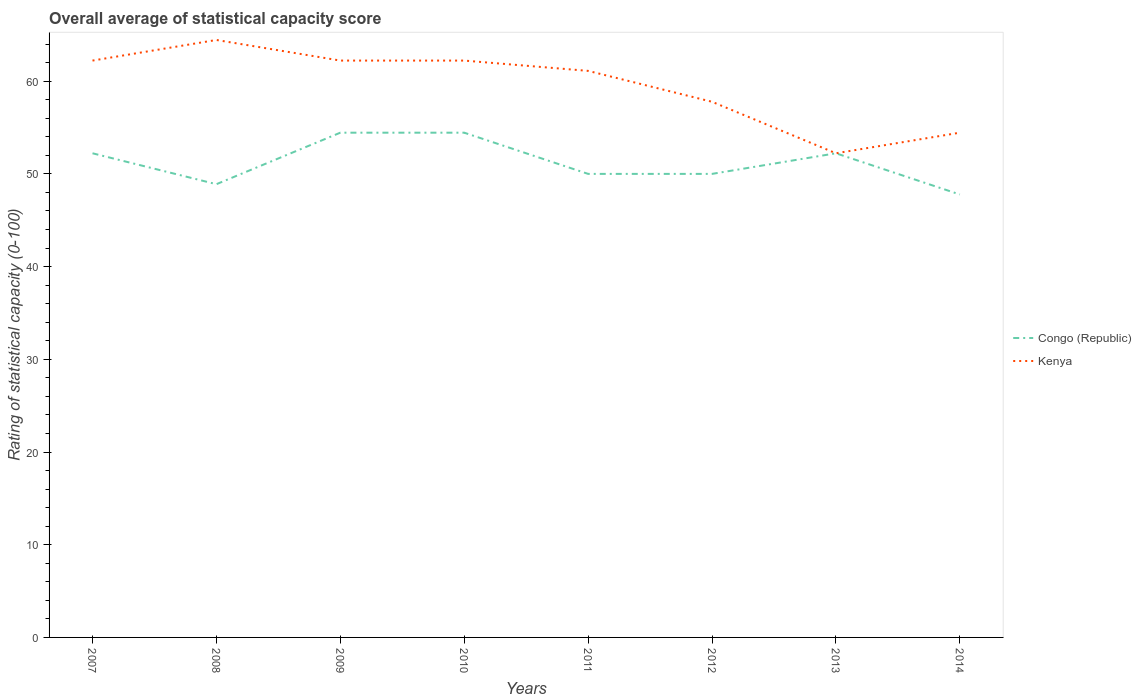Does the line corresponding to Congo (Republic) intersect with the line corresponding to Kenya?
Your response must be concise. Yes. Is the number of lines equal to the number of legend labels?
Offer a terse response. Yes. Across all years, what is the maximum rating of statistical capacity in Congo (Republic)?
Your response must be concise. 47.78. In which year was the rating of statistical capacity in Congo (Republic) maximum?
Your answer should be very brief. 2014. What is the total rating of statistical capacity in Congo (Republic) in the graph?
Offer a very short reply. 0. What is the difference between the highest and the second highest rating of statistical capacity in Kenya?
Your response must be concise. 12.22. Is the rating of statistical capacity in Congo (Republic) strictly greater than the rating of statistical capacity in Kenya over the years?
Keep it short and to the point. No. How many years are there in the graph?
Your response must be concise. 8. Are the values on the major ticks of Y-axis written in scientific E-notation?
Your answer should be compact. No. Does the graph contain any zero values?
Your answer should be very brief. No. Does the graph contain grids?
Your response must be concise. No. How many legend labels are there?
Offer a very short reply. 2. What is the title of the graph?
Offer a very short reply. Overall average of statistical capacity score. What is the label or title of the X-axis?
Make the answer very short. Years. What is the label or title of the Y-axis?
Make the answer very short. Rating of statistical capacity (0-100). What is the Rating of statistical capacity (0-100) in Congo (Republic) in 2007?
Offer a terse response. 52.22. What is the Rating of statistical capacity (0-100) of Kenya in 2007?
Provide a short and direct response. 62.22. What is the Rating of statistical capacity (0-100) of Congo (Republic) in 2008?
Offer a very short reply. 48.89. What is the Rating of statistical capacity (0-100) of Kenya in 2008?
Provide a succinct answer. 64.44. What is the Rating of statistical capacity (0-100) in Congo (Republic) in 2009?
Provide a succinct answer. 54.44. What is the Rating of statistical capacity (0-100) of Kenya in 2009?
Your answer should be very brief. 62.22. What is the Rating of statistical capacity (0-100) in Congo (Republic) in 2010?
Your answer should be compact. 54.44. What is the Rating of statistical capacity (0-100) of Kenya in 2010?
Keep it short and to the point. 62.22. What is the Rating of statistical capacity (0-100) in Kenya in 2011?
Give a very brief answer. 61.11. What is the Rating of statistical capacity (0-100) in Congo (Republic) in 2012?
Make the answer very short. 50. What is the Rating of statistical capacity (0-100) in Kenya in 2012?
Offer a terse response. 57.78. What is the Rating of statistical capacity (0-100) in Congo (Republic) in 2013?
Your response must be concise. 52.22. What is the Rating of statistical capacity (0-100) in Kenya in 2013?
Your response must be concise. 52.22. What is the Rating of statistical capacity (0-100) in Congo (Republic) in 2014?
Give a very brief answer. 47.78. What is the Rating of statistical capacity (0-100) in Kenya in 2014?
Ensure brevity in your answer.  54.44. Across all years, what is the maximum Rating of statistical capacity (0-100) of Congo (Republic)?
Keep it short and to the point. 54.44. Across all years, what is the maximum Rating of statistical capacity (0-100) in Kenya?
Provide a succinct answer. 64.44. Across all years, what is the minimum Rating of statistical capacity (0-100) of Congo (Republic)?
Your response must be concise. 47.78. Across all years, what is the minimum Rating of statistical capacity (0-100) of Kenya?
Keep it short and to the point. 52.22. What is the total Rating of statistical capacity (0-100) in Congo (Republic) in the graph?
Keep it short and to the point. 410. What is the total Rating of statistical capacity (0-100) in Kenya in the graph?
Your answer should be compact. 476.67. What is the difference between the Rating of statistical capacity (0-100) of Congo (Republic) in 2007 and that in 2008?
Offer a very short reply. 3.33. What is the difference between the Rating of statistical capacity (0-100) in Kenya in 2007 and that in 2008?
Offer a very short reply. -2.22. What is the difference between the Rating of statistical capacity (0-100) in Congo (Republic) in 2007 and that in 2009?
Provide a succinct answer. -2.22. What is the difference between the Rating of statistical capacity (0-100) in Kenya in 2007 and that in 2009?
Provide a short and direct response. 0. What is the difference between the Rating of statistical capacity (0-100) in Congo (Republic) in 2007 and that in 2010?
Offer a very short reply. -2.22. What is the difference between the Rating of statistical capacity (0-100) of Congo (Republic) in 2007 and that in 2011?
Give a very brief answer. 2.22. What is the difference between the Rating of statistical capacity (0-100) in Congo (Republic) in 2007 and that in 2012?
Make the answer very short. 2.22. What is the difference between the Rating of statistical capacity (0-100) in Kenya in 2007 and that in 2012?
Your answer should be very brief. 4.44. What is the difference between the Rating of statistical capacity (0-100) in Kenya in 2007 and that in 2013?
Offer a terse response. 10. What is the difference between the Rating of statistical capacity (0-100) in Congo (Republic) in 2007 and that in 2014?
Make the answer very short. 4.44. What is the difference between the Rating of statistical capacity (0-100) in Kenya in 2007 and that in 2014?
Keep it short and to the point. 7.78. What is the difference between the Rating of statistical capacity (0-100) in Congo (Republic) in 2008 and that in 2009?
Your response must be concise. -5.56. What is the difference between the Rating of statistical capacity (0-100) in Kenya in 2008 and that in 2009?
Ensure brevity in your answer.  2.22. What is the difference between the Rating of statistical capacity (0-100) of Congo (Republic) in 2008 and that in 2010?
Your answer should be very brief. -5.56. What is the difference between the Rating of statistical capacity (0-100) in Kenya in 2008 and that in 2010?
Offer a very short reply. 2.22. What is the difference between the Rating of statistical capacity (0-100) of Congo (Republic) in 2008 and that in 2011?
Make the answer very short. -1.11. What is the difference between the Rating of statistical capacity (0-100) of Kenya in 2008 and that in 2011?
Ensure brevity in your answer.  3.33. What is the difference between the Rating of statistical capacity (0-100) of Congo (Republic) in 2008 and that in 2012?
Keep it short and to the point. -1.11. What is the difference between the Rating of statistical capacity (0-100) of Kenya in 2008 and that in 2013?
Offer a terse response. 12.22. What is the difference between the Rating of statistical capacity (0-100) in Congo (Republic) in 2008 and that in 2014?
Give a very brief answer. 1.11. What is the difference between the Rating of statistical capacity (0-100) in Kenya in 2008 and that in 2014?
Offer a very short reply. 10. What is the difference between the Rating of statistical capacity (0-100) in Congo (Republic) in 2009 and that in 2010?
Your answer should be very brief. 0. What is the difference between the Rating of statistical capacity (0-100) in Kenya in 2009 and that in 2010?
Keep it short and to the point. 0. What is the difference between the Rating of statistical capacity (0-100) in Congo (Republic) in 2009 and that in 2011?
Your response must be concise. 4.44. What is the difference between the Rating of statistical capacity (0-100) of Kenya in 2009 and that in 2011?
Provide a short and direct response. 1.11. What is the difference between the Rating of statistical capacity (0-100) in Congo (Republic) in 2009 and that in 2012?
Make the answer very short. 4.44. What is the difference between the Rating of statistical capacity (0-100) of Kenya in 2009 and that in 2012?
Offer a very short reply. 4.44. What is the difference between the Rating of statistical capacity (0-100) of Congo (Republic) in 2009 and that in 2013?
Offer a very short reply. 2.22. What is the difference between the Rating of statistical capacity (0-100) of Kenya in 2009 and that in 2013?
Give a very brief answer. 10. What is the difference between the Rating of statistical capacity (0-100) in Congo (Republic) in 2009 and that in 2014?
Your answer should be very brief. 6.67. What is the difference between the Rating of statistical capacity (0-100) in Kenya in 2009 and that in 2014?
Offer a terse response. 7.78. What is the difference between the Rating of statistical capacity (0-100) of Congo (Republic) in 2010 and that in 2011?
Provide a short and direct response. 4.44. What is the difference between the Rating of statistical capacity (0-100) in Congo (Republic) in 2010 and that in 2012?
Provide a succinct answer. 4.44. What is the difference between the Rating of statistical capacity (0-100) in Kenya in 2010 and that in 2012?
Offer a terse response. 4.44. What is the difference between the Rating of statistical capacity (0-100) in Congo (Republic) in 2010 and that in 2013?
Give a very brief answer. 2.22. What is the difference between the Rating of statistical capacity (0-100) in Kenya in 2010 and that in 2013?
Make the answer very short. 10. What is the difference between the Rating of statistical capacity (0-100) of Kenya in 2010 and that in 2014?
Offer a very short reply. 7.78. What is the difference between the Rating of statistical capacity (0-100) in Congo (Republic) in 2011 and that in 2013?
Your response must be concise. -2.22. What is the difference between the Rating of statistical capacity (0-100) in Kenya in 2011 and that in 2013?
Your answer should be very brief. 8.89. What is the difference between the Rating of statistical capacity (0-100) of Congo (Republic) in 2011 and that in 2014?
Your answer should be compact. 2.22. What is the difference between the Rating of statistical capacity (0-100) in Kenya in 2011 and that in 2014?
Offer a terse response. 6.67. What is the difference between the Rating of statistical capacity (0-100) of Congo (Republic) in 2012 and that in 2013?
Provide a short and direct response. -2.22. What is the difference between the Rating of statistical capacity (0-100) in Kenya in 2012 and that in 2013?
Ensure brevity in your answer.  5.56. What is the difference between the Rating of statistical capacity (0-100) in Congo (Republic) in 2012 and that in 2014?
Your answer should be very brief. 2.22. What is the difference between the Rating of statistical capacity (0-100) in Kenya in 2012 and that in 2014?
Provide a short and direct response. 3.33. What is the difference between the Rating of statistical capacity (0-100) in Congo (Republic) in 2013 and that in 2014?
Offer a terse response. 4.44. What is the difference between the Rating of statistical capacity (0-100) in Kenya in 2013 and that in 2014?
Your answer should be very brief. -2.22. What is the difference between the Rating of statistical capacity (0-100) in Congo (Republic) in 2007 and the Rating of statistical capacity (0-100) in Kenya in 2008?
Provide a succinct answer. -12.22. What is the difference between the Rating of statistical capacity (0-100) in Congo (Republic) in 2007 and the Rating of statistical capacity (0-100) in Kenya in 2011?
Your answer should be compact. -8.89. What is the difference between the Rating of statistical capacity (0-100) of Congo (Republic) in 2007 and the Rating of statistical capacity (0-100) of Kenya in 2012?
Your answer should be compact. -5.56. What is the difference between the Rating of statistical capacity (0-100) of Congo (Republic) in 2007 and the Rating of statistical capacity (0-100) of Kenya in 2013?
Your answer should be very brief. 0. What is the difference between the Rating of statistical capacity (0-100) in Congo (Republic) in 2007 and the Rating of statistical capacity (0-100) in Kenya in 2014?
Provide a short and direct response. -2.22. What is the difference between the Rating of statistical capacity (0-100) of Congo (Republic) in 2008 and the Rating of statistical capacity (0-100) of Kenya in 2009?
Provide a short and direct response. -13.33. What is the difference between the Rating of statistical capacity (0-100) in Congo (Republic) in 2008 and the Rating of statistical capacity (0-100) in Kenya in 2010?
Provide a short and direct response. -13.33. What is the difference between the Rating of statistical capacity (0-100) in Congo (Republic) in 2008 and the Rating of statistical capacity (0-100) in Kenya in 2011?
Provide a short and direct response. -12.22. What is the difference between the Rating of statistical capacity (0-100) in Congo (Republic) in 2008 and the Rating of statistical capacity (0-100) in Kenya in 2012?
Provide a succinct answer. -8.89. What is the difference between the Rating of statistical capacity (0-100) in Congo (Republic) in 2008 and the Rating of statistical capacity (0-100) in Kenya in 2013?
Keep it short and to the point. -3.33. What is the difference between the Rating of statistical capacity (0-100) in Congo (Republic) in 2008 and the Rating of statistical capacity (0-100) in Kenya in 2014?
Make the answer very short. -5.56. What is the difference between the Rating of statistical capacity (0-100) in Congo (Republic) in 2009 and the Rating of statistical capacity (0-100) in Kenya in 2010?
Keep it short and to the point. -7.78. What is the difference between the Rating of statistical capacity (0-100) of Congo (Republic) in 2009 and the Rating of statistical capacity (0-100) of Kenya in 2011?
Your answer should be very brief. -6.67. What is the difference between the Rating of statistical capacity (0-100) in Congo (Republic) in 2009 and the Rating of statistical capacity (0-100) in Kenya in 2012?
Make the answer very short. -3.33. What is the difference between the Rating of statistical capacity (0-100) in Congo (Republic) in 2009 and the Rating of statistical capacity (0-100) in Kenya in 2013?
Your response must be concise. 2.22. What is the difference between the Rating of statistical capacity (0-100) in Congo (Republic) in 2009 and the Rating of statistical capacity (0-100) in Kenya in 2014?
Provide a short and direct response. 0. What is the difference between the Rating of statistical capacity (0-100) of Congo (Republic) in 2010 and the Rating of statistical capacity (0-100) of Kenya in 2011?
Keep it short and to the point. -6.67. What is the difference between the Rating of statistical capacity (0-100) of Congo (Republic) in 2010 and the Rating of statistical capacity (0-100) of Kenya in 2013?
Your answer should be very brief. 2.22. What is the difference between the Rating of statistical capacity (0-100) in Congo (Republic) in 2010 and the Rating of statistical capacity (0-100) in Kenya in 2014?
Keep it short and to the point. 0. What is the difference between the Rating of statistical capacity (0-100) of Congo (Republic) in 2011 and the Rating of statistical capacity (0-100) of Kenya in 2012?
Offer a very short reply. -7.78. What is the difference between the Rating of statistical capacity (0-100) in Congo (Republic) in 2011 and the Rating of statistical capacity (0-100) in Kenya in 2013?
Provide a succinct answer. -2.22. What is the difference between the Rating of statistical capacity (0-100) in Congo (Republic) in 2011 and the Rating of statistical capacity (0-100) in Kenya in 2014?
Offer a very short reply. -4.44. What is the difference between the Rating of statistical capacity (0-100) in Congo (Republic) in 2012 and the Rating of statistical capacity (0-100) in Kenya in 2013?
Offer a very short reply. -2.22. What is the difference between the Rating of statistical capacity (0-100) of Congo (Republic) in 2012 and the Rating of statistical capacity (0-100) of Kenya in 2014?
Ensure brevity in your answer.  -4.44. What is the difference between the Rating of statistical capacity (0-100) of Congo (Republic) in 2013 and the Rating of statistical capacity (0-100) of Kenya in 2014?
Ensure brevity in your answer.  -2.22. What is the average Rating of statistical capacity (0-100) of Congo (Republic) per year?
Make the answer very short. 51.25. What is the average Rating of statistical capacity (0-100) of Kenya per year?
Offer a terse response. 59.58. In the year 2008, what is the difference between the Rating of statistical capacity (0-100) of Congo (Republic) and Rating of statistical capacity (0-100) of Kenya?
Provide a succinct answer. -15.56. In the year 2009, what is the difference between the Rating of statistical capacity (0-100) in Congo (Republic) and Rating of statistical capacity (0-100) in Kenya?
Make the answer very short. -7.78. In the year 2010, what is the difference between the Rating of statistical capacity (0-100) in Congo (Republic) and Rating of statistical capacity (0-100) in Kenya?
Provide a succinct answer. -7.78. In the year 2011, what is the difference between the Rating of statistical capacity (0-100) in Congo (Republic) and Rating of statistical capacity (0-100) in Kenya?
Make the answer very short. -11.11. In the year 2012, what is the difference between the Rating of statistical capacity (0-100) of Congo (Republic) and Rating of statistical capacity (0-100) of Kenya?
Your answer should be very brief. -7.78. In the year 2013, what is the difference between the Rating of statistical capacity (0-100) in Congo (Republic) and Rating of statistical capacity (0-100) in Kenya?
Your answer should be very brief. 0. In the year 2014, what is the difference between the Rating of statistical capacity (0-100) of Congo (Republic) and Rating of statistical capacity (0-100) of Kenya?
Provide a short and direct response. -6.67. What is the ratio of the Rating of statistical capacity (0-100) in Congo (Republic) in 2007 to that in 2008?
Offer a terse response. 1.07. What is the ratio of the Rating of statistical capacity (0-100) in Kenya in 2007 to that in 2008?
Make the answer very short. 0.97. What is the ratio of the Rating of statistical capacity (0-100) in Congo (Republic) in 2007 to that in 2009?
Your response must be concise. 0.96. What is the ratio of the Rating of statistical capacity (0-100) in Congo (Republic) in 2007 to that in 2010?
Offer a very short reply. 0.96. What is the ratio of the Rating of statistical capacity (0-100) of Kenya in 2007 to that in 2010?
Provide a short and direct response. 1. What is the ratio of the Rating of statistical capacity (0-100) in Congo (Republic) in 2007 to that in 2011?
Your response must be concise. 1.04. What is the ratio of the Rating of statistical capacity (0-100) in Kenya in 2007 to that in 2011?
Ensure brevity in your answer.  1.02. What is the ratio of the Rating of statistical capacity (0-100) of Congo (Republic) in 2007 to that in 2012?
Ensure brevity in your answer.  1.04. What is the ratio of the Rating of statistical capacity (0-100) of Congo (Republic) in 2007 to that in 2013?
Offer a very short reply. 1. What is the ratio of the Rating of statistical capacity (0-100) in Kenya in 2007 to that in 2013?
Your answer should be very brief. 1.19. What is the ratio of the Rating of statistical capacity (0-100) of Congo (Republic) in 2007 to that in 2014?
Make the answer very short. 1.09. What is the ratio of the Rating of statistical capacity (0-100) of Kenya in 2007 to that in 2014?
Provide a succinct answer. 1.14. What is the ratio of the Rating of statistical capacity (0-100) of Congo (Republic) in 2008 to that in 2009?
Your answer should be compact. 0.9. What is the ratio of the Rating of statistical capacity (0-100) in Kenya in 2008 to that in 2009?
Your response must be concise. 1.04. What is the ratio of the Rating of statistical capacity (0-100) of Congo (Republic) in 2008 to that in 2010?
Your answer should be very brief. 0.9. What is the ratio of the Rating of statistical capacity (0-100) of Kenya in 2008 to that in 2010?
Offer a very short reply. 1.04. What is the ratio of the Rating of statistical capacity (0-100) in Congo (Republic) in 2008 to that in 2011?
Provide a short and direct response. 0.98. What is the ratio of the Rating of statistical capacity (0-100) of Kenya in 2008 to that in 2011?
Your answer should be very brief. 1.05. What is the ratio of the Rating of statistical capacity (0-100) of Congo (Republic) in 2008 to that in 2012?
Your answer should be very brief. 0.98. What is the ratio of the Rating of statistical capacity (0-100) of Kenya in 2008 to that in 2012?
Your response must be concise. 1.12. What is the ratio of the Rating of statistical capacity (0-100) in Congo (Republic) in 2008 to that in 2013?
Make the answer very short. 0.94. What is the ratio of the Rating of statistical capacity (0-100) of Kenya in 2008 to that in 2013?
Provide a succinct answer. 1.23. What is the ratio of the Rating of statistical capacity (0-100) of Congo (Republic) in 2008 to that in 2014?
Provide a succinct answer. 1.02. What is the ratio of the Rating of statistical capacity (0-100) in Kenya in 2008 to that in 2014?
Your answer should be very brief. 1.18. What is the ratio of the Rating of statistical capacity (0-100) in Congo (Republic) in 2009 to that in 2010?
Your answer should be compact. 1. What is the ratio of the Rating of statistical capacity (0-100) in Kenya in 2009 to that in 2010?
Provide a succinct answer. 1. What is the ratio of the Rating of statistical capacity (0-100) of Congo (Republic) in 2009 to that in 2011?
Provide a succinct answer. 1.09. What is the ratio of the Rating of statistical capacity (0-100) in Kenya in 2009 to that in 2011?
Provide a succinct answer. 1.02. What is the ratio of the Rating of statistical capacity (0-100) in Congo (Republic) in 2009 to that in 2012?
Offer a terse response. 1.09. What is the ratio of the Rating of statistical capacity (0-100) in Congo (Republic) in 2009 to that in 2013?
Offer a very short reply. 1.04. What is the ratio of the Rating of statistical capacity (0-100) of Kenya in 2009 to that in 2013?
Your answer should be compact. 1.19. What is the ratio of the Rating of statistical capacity (0-100) of Congo (Republic) in 2009 to that in 2014?
Offer a very short reply. 1.14. What is the ratio of the Rating of statistical capacity (0-100) in Congo (Republic) in 2010 to that in 2011?
Ensure brevity in your answer.  1.09. What is the ratio of the Rating of statistical capacity (0-100) in Kenya in 2010 to that in 2011?
Give a very brief answer. 1.02. What is the ratio of the Rating of statistical capacity (0-100) in Congo (Republic) in 2010 to that in 2012?
Make the answer very short. 1.09. What is the ratio of the Rating of statistical capacity (0-100) of Congo (Republic) in 2010 to that in 2013?
Give a very brief answer. 1.04. What is the ratio of the Rating of statistical capacity (0-100) of Kenya in 2010 to that in 2013?
Your answer should be very brief. 1.19. What is the ratio of the Rating of statistical capacity (0-100) of Congo (Republic) in 2010 to that in 2014?
Offer a terse response. 1.14. What is the ratio of the Rating of statistical capacity (0-100) in Congo (Republic) in 2011 to that in 2012?
Offer a terse response. 1. What is the ratio of the Rating of statistical capacity (0-100) of Kenya in 2011 to that in 2012?
Offer a very short reply. 1.06. What is the ratio of the Rating of statistical capacity (0-100) of Congo (Republic) in 2011 to that in 2013?
Keep it short and to the point. 0.96. What is the ratio of the Rating of statistical capacity (0-100) in Kenya in 2011 to that in 2013?
Keep it short and to the point. 1.17. What is the ratio of the Rating of statistical capacity (0-100) of Congo (Republic) in 2011 to that in 2014?
Give a very brief answer. 1.05. What is the ratio of the Rating of statistical capacity (0-100) of Kenya in 2011 to that in 2014?
Provide a short and direct response. 1.12. What is the ratio of the Rating of statistical capacity (0-100) in Congo (Republic) in 2012 to that in 2013?
Your answer should be compact. 0.96. What is the ratio of the Rating of statistical capacity (0-100) in Kenya in 2012 to that in 2013?
Make the answer very short. 1.11. What is the ratio of the Rating of statistical capacity (0-100) of Congo (Republic) in 2012 to that in 2014?
Make the answer very short. 1.05. What is the ratio of the Rating of statistical capacity (0-100) of Kenya in 2012 to that in 2014?
Offer a terse response. 1.06. What is the ratio of the Rating of statistical capacity (0-100) in Congo (Republic) in 2013 to that in 2014?
Offer a very short reply. 1.09. What is the ratio of the Rating of statistical capacity (0-100) of Kenya in 2013 to that in 2014?
Make the answer very short. 0.96. What is the difference between the highest and the second highest Rating of statistical capacity (0-100) in Kenya?
Give a very brief answer. 2.22. What is the difference between the highest and the lowest Rating of statistical capacity (0-100) in Kenya?
Ensure brevity in your answer.  12.22. 